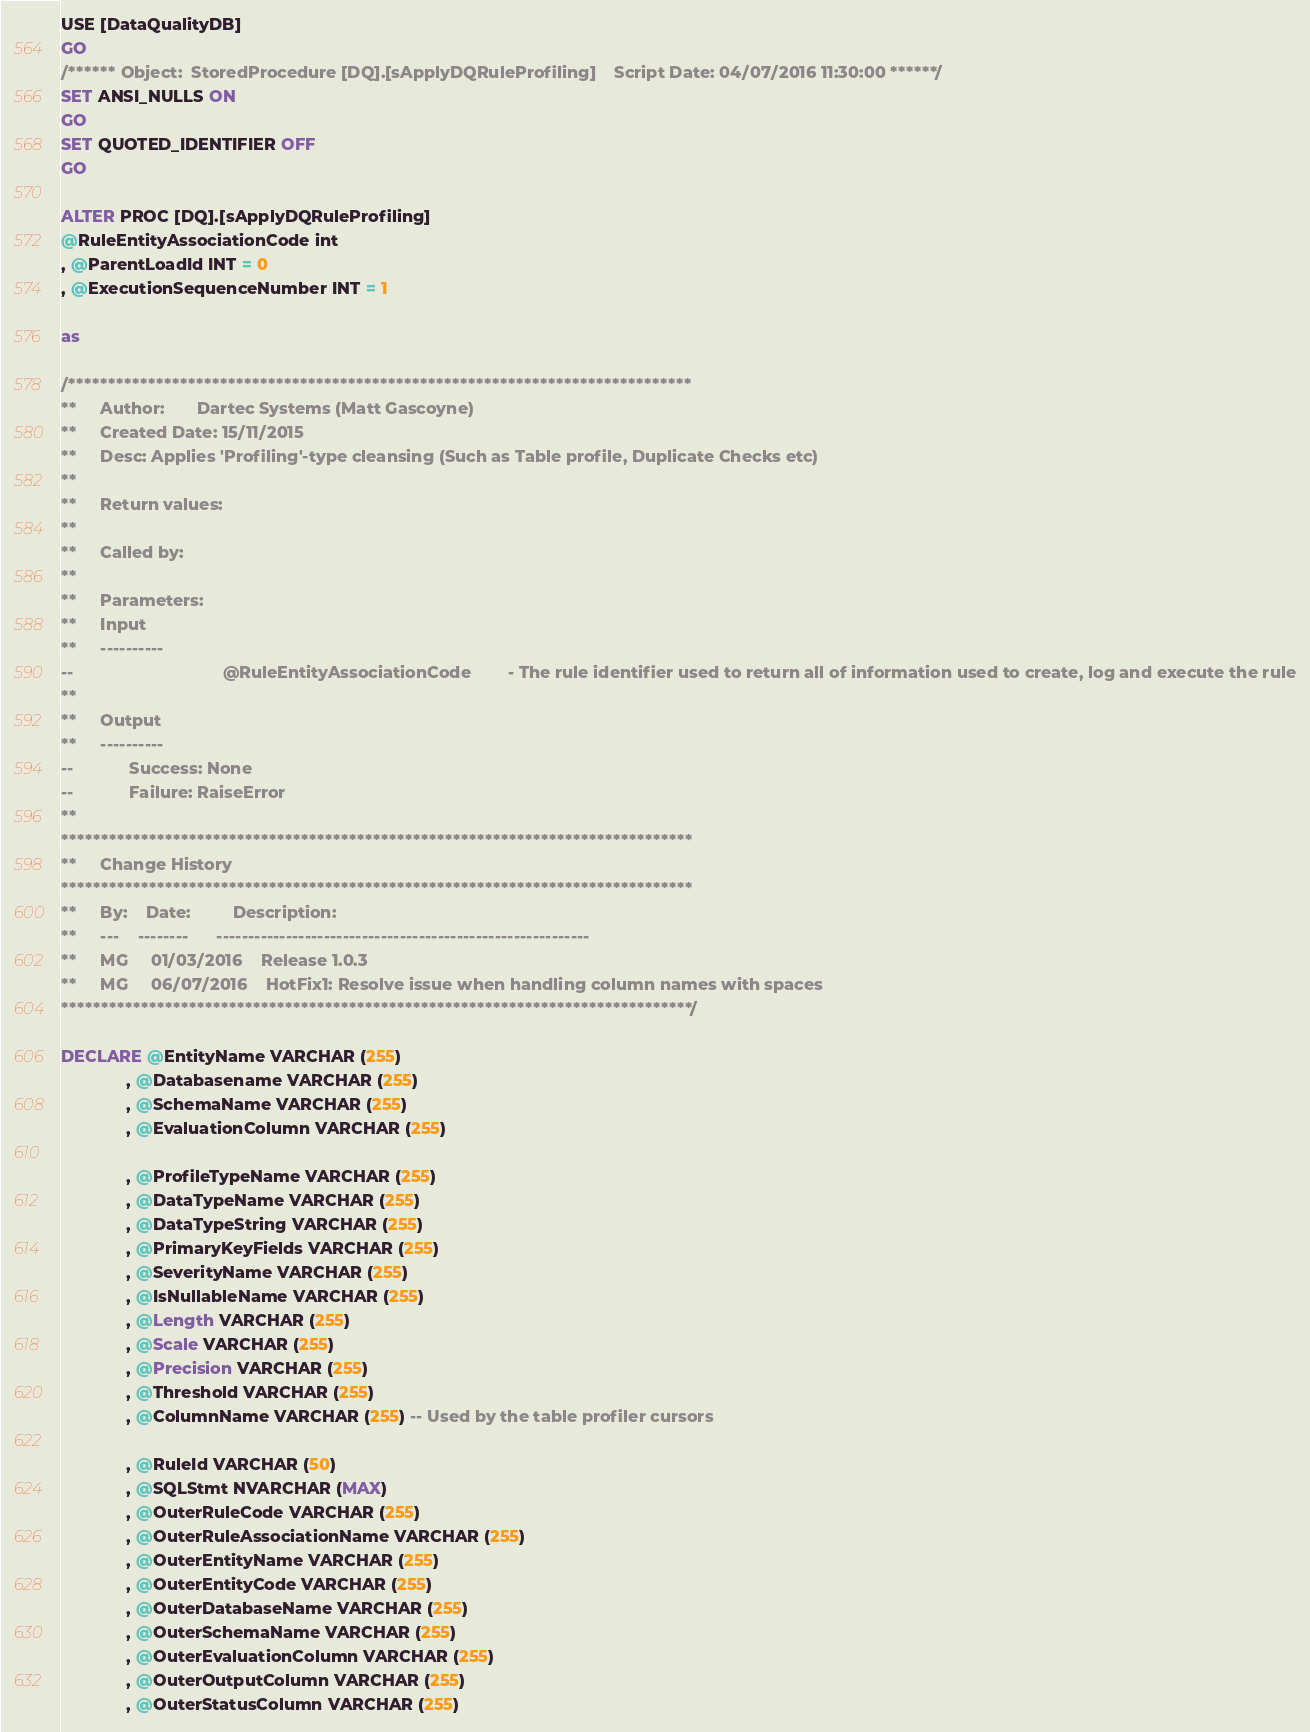<code> <loc_0><loc_0><loc_500><loc_500><_SQL_>USE [DataQualityDB]
GO
/****** Object:  StoredProcedure [DQ].[sApplyDQRuleProfiling]    Script Date: 04/07/2016 11:30:00 ******/
SET ANSI_NULLS ON
GO
SET QUOTED_IDENTIFIER OFF
GO

ALTER PROC [DQ].[sApplyDQRuleProfiling] 
@RuleEntityAssociationCode int
, @ParentLoadId INT = 0
, @ExecutionSequenceNumber INT = 1

as

/******************************************************************************
**     Author:       Dartec Systems (Matt Gascoyne)
**     Created Date: 15/11/2015
**     Desc: Applies 'Profiling'-type cleansing (Such as Table profile, Duplicate Checks etc)
**
**     Return values:
**
**     Called by:
**             
**     Parameters:
**     Input
**     ----------
--                                @RuleEntityAssociationCode        - The rule identifier used to return all of information used to create, log and execute the rule
**
**     Output
**     ----------
--            Success: None
--            Failure: RaiseError               
** 
*******************************************************************************
**     Change History
*******************************************************************************
**     By:    Date:         Description:
**     ---    --------      -----------------------------------------------------------
**     MG     01/03/2016    Release 1.0.3
**     MG     06/07/2016    HotFix1: Resolve issue when handling column names with spaces 
*******************************************************************************/

DECLARE @EntityName VARCHAR (255)
              , @Databasename VARCHAR (255)
              , @SchemaName VARCHAR (255)
              , @EvaluationColumn VARCHAR (255)
              
              , @ProfileTypeName VARCHAR (255)
              , @DataTypeName VARCHAR (255)
              , @DataTypeString VARCHAR (255)
              , @PrimaryKeyFields VARCHAR (255)
              , @SeverityName VARCHAR (255)
              , @IsNullableName VARCHAR (255)
              , @Length VARCHAR (255)
              , @Scale VARCHAR (255)
              , @Precision VARCHAR (255)
              , @Threshold VARCHAR (255)
              , @ColumnName VARCHAR (255) -- Used by the table profiler cursors

              , @RuleId VARCHAR (50)
              , @SQLStmt NVARCHAR (MAX)
              , @OuterRuleCode VARCHAR (255)
              , @OuterRuleAssociationName VARCHAR (255)
              , @OuterEntityName VARCHAR (255)
              , @OuterEntityCode VARCHAR (255)
              , @OuterDatabaseName VARCHAR (255)
              , @OuterSchemaName VARCHAR (255)
              , @OuterEvaluationColumn VARCHAR (255)
              , @OuterOutputColumn VARCHAR (255)
              , @OuterStatusColumn VARCHAR (255)</code> 